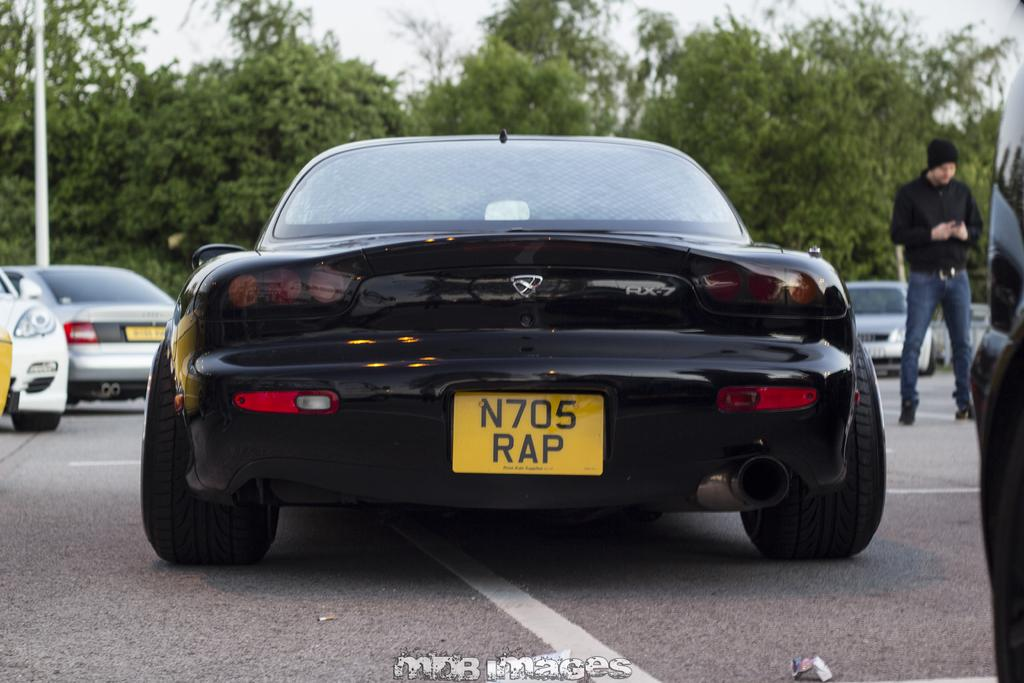What type of vehicles can be seen in the image? There are cars in the image. What other elements are present in the image besides cars? There are trees and a person wearing a black color jacket in the image. What can be seen in the sky in the image? The sky is visible in the image. How many toes can be seen on the person wearing a black color jacket in the image? There is no visible indication of the person's toes in the image. Is there a squirrel visible in the image? There is no squirrel present in the image. 